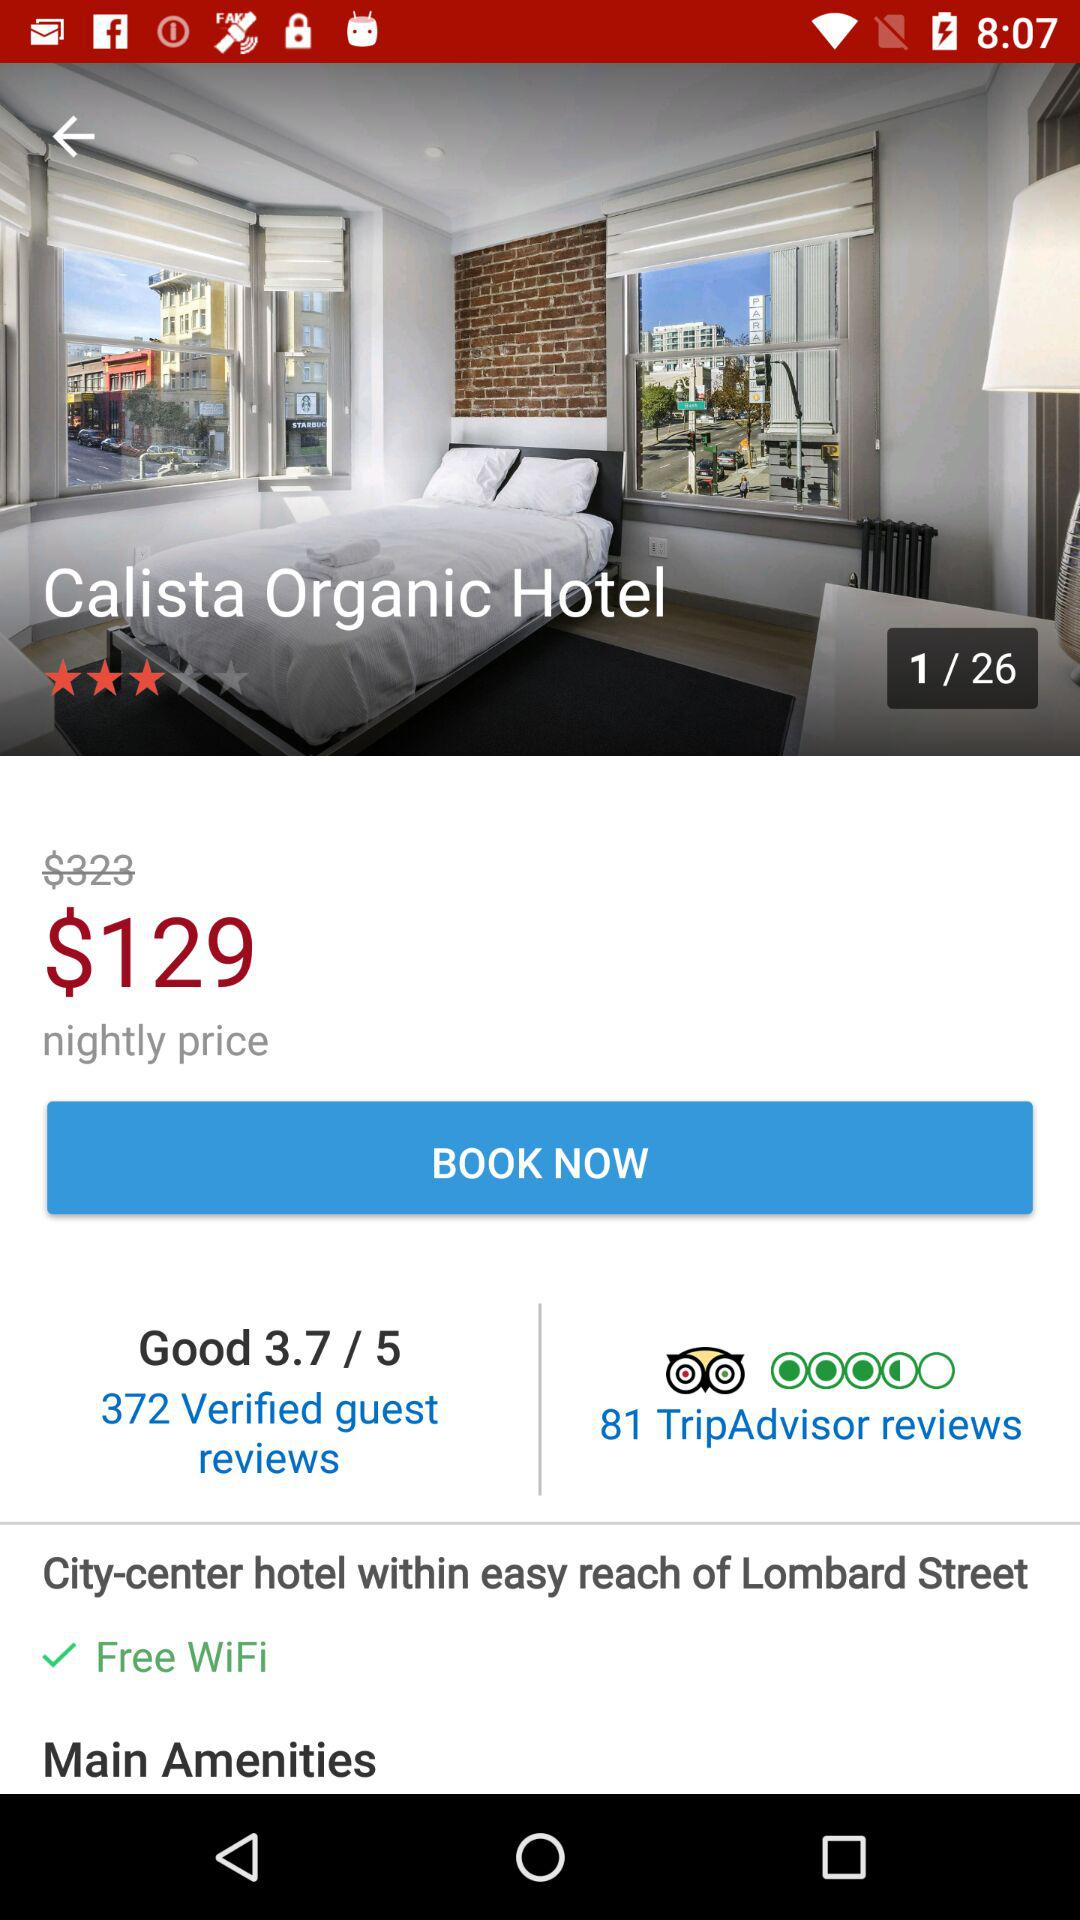What is the name of the hotel? The name of the hotel is "Calista Organic Hotel". 